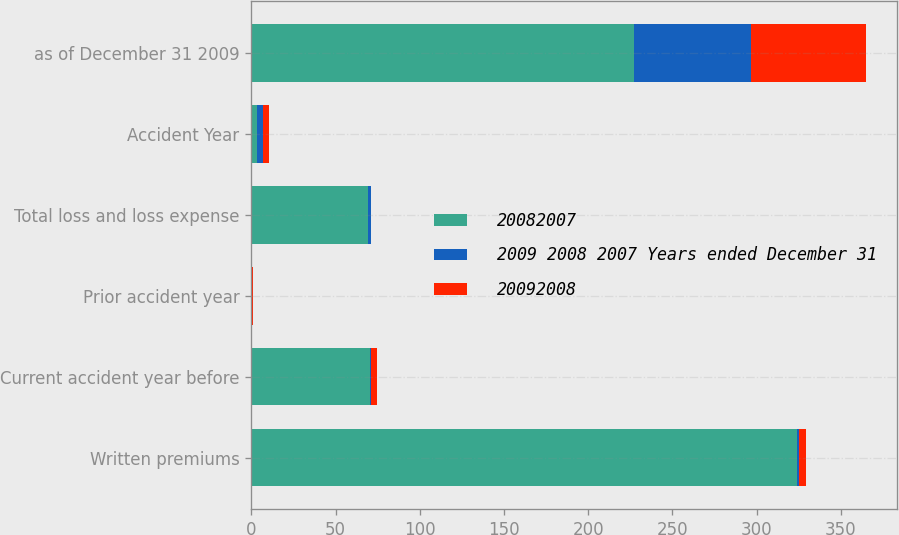Convert chart to OTSL. <chart><loc_0><loc_0><loc_500><loc_500><stacked_bar_chart><ecel><fcel>Written premiums<fcel>Current accident year before<fcel>Prior accident year<fcel>Total loss and loss expense<fcel>Accident Year<fcel>as of December 31 2009<nl><fcel>20082007<fcel>324<fcel>70.2<fcel>0.2<fcel>69<fcel>3.6<fcel>227<nl><fcel>2009 2008 2007 Years ended December 31<fcel>1.3<fcel>0.8<fcel>0.2<fcel>1.8<fcel>3.6<fcel>69.8<nl><fcel>20092008<fcel>3.7<fcel>3.6<fcel>0.9<fcel>0.4<fcel>3.6<fcel>68.3<nl></chart> 